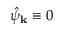Convert formula to latex. <formula><loc_0><loc_0><loc_500><loc_500>\hat { \psi } _ { k } \equiv 0</formula> 